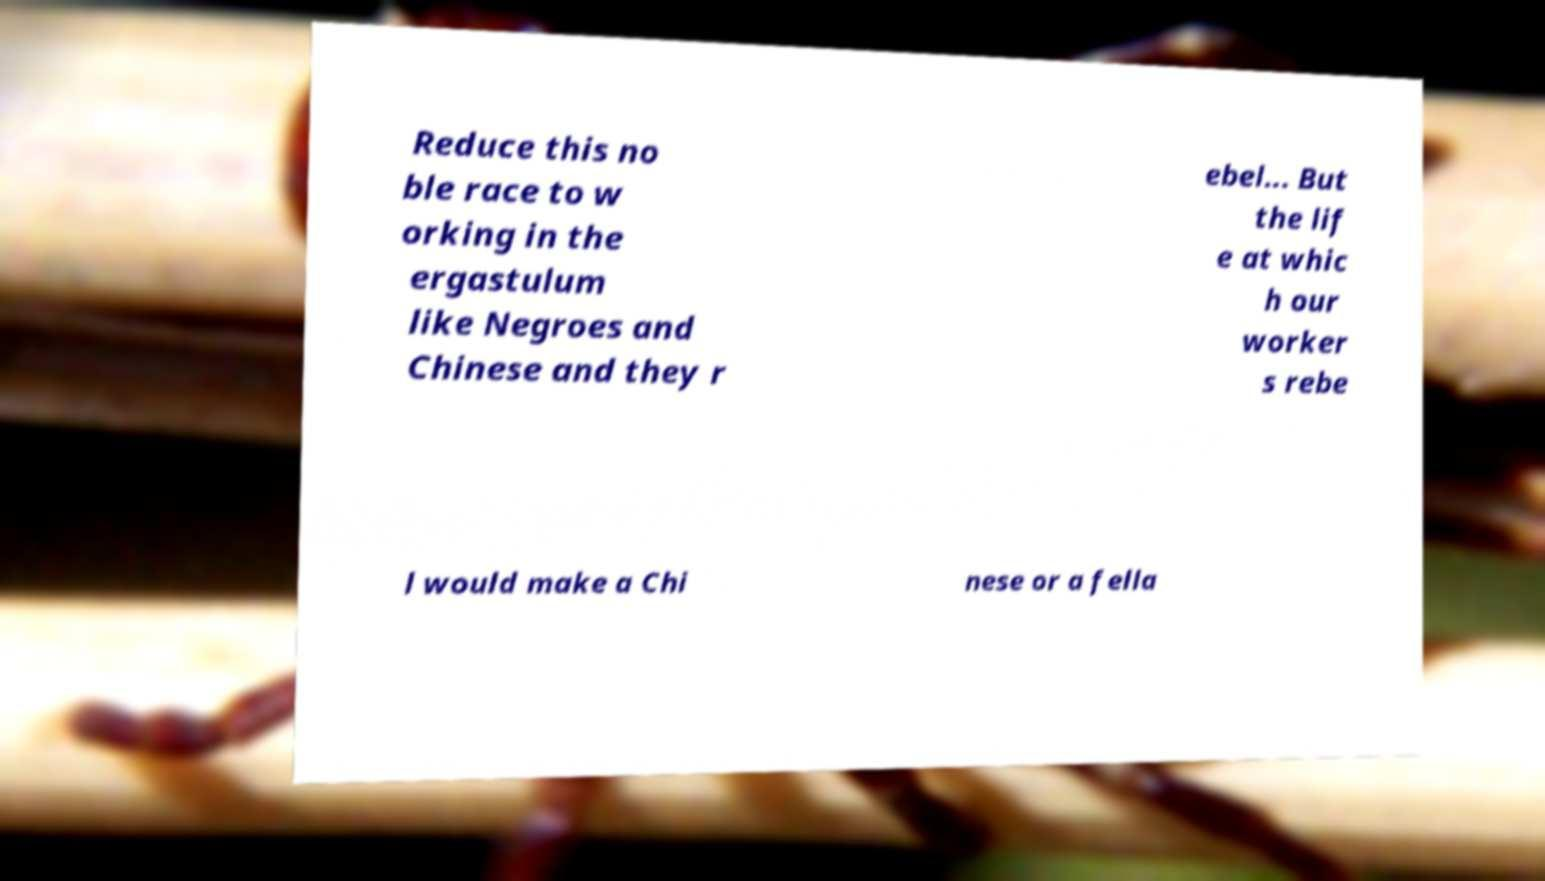Can you read and provide the text displayed in the image?This photo seems to have some interesting text. Can you extract and type it out for me? Reduce this no ble race to w orking in the ergastulum like Negroes and Chinese and they r ebel... But the lif e at whic h our worker s rebe l would make a Chi nese or a fella 